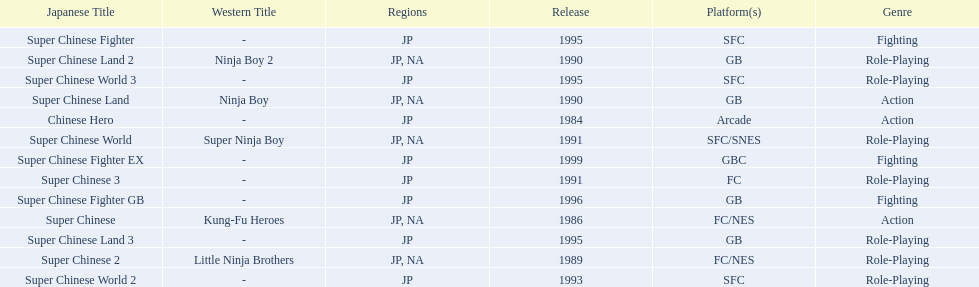Which titles were released in north america? Super Chinese, Super Chinese 2, Super Chinese Land, Super Chinese Land 2, Super Chinese World. Of those, which had the least releases? Super Chinese World. 